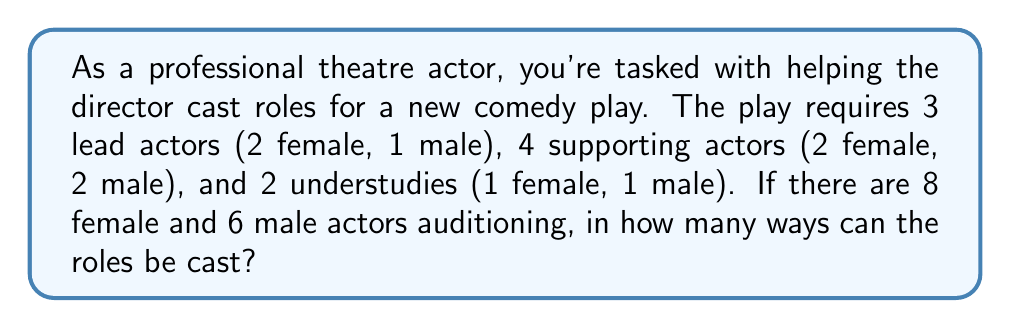Could you help me with this problem? Let's break this down step-by-step:

1) First, let's cast the lead roles:
   - 2 female leads: We choose 2 out of 8 female actors: $\binom{8}{2}$
   - 1 male lead: We choose 1 out of 6 male actors: $\binom{6}{1}$

2) For supporting roles:
   - 2 female supporting: We choose 2 out of the remaining 6 female actors: $\binom{6}{2}$
   - 2 male supporting: We choose 2 out of the remaining 5 male actors: $\binom{5}{2}$

3) For understudies:
   - 1 female understudy: We choose 1 out of the remaining 4 female actors: $\binom{4}{1}$
   - 1 male understudy: We choose 1 out of the remaining 3 male actors: $\binom{3}{1}$

4) By the multiplication principle, the total number of ways to cast the roles is the product of all these combinations:

   $$\binom{8}{2} \cdot \binom{6}{1} \cdot \binom{6}{2} \cdot \binom{5}{2} \cdot \binom{4}{1} \cdot \binom{3}{1}$$

5) Let's calculate each combination:
   $$\binom{8}{2} = 28, \binom{6}{1} = 6, \binom{6}{2} = 15, \binom{5}{2} = 10, \binom{4}{1} = 4, \binom{3}{1} = 3$$

6) Multiplying these numbers:

   $$28 \cdot 6 \cdot 15 \cdot 10 \cdot 4 \cdot 3 = 302,400$$

Therefore, there are 302,400 ways to cast the roles for this play.
Answer: 302,400 